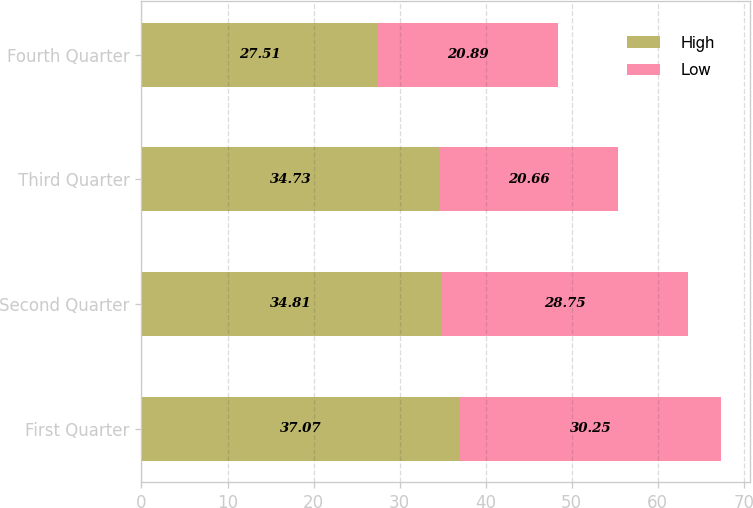Convert chart to OTSL. <chart><loc_0><loc_0><loc_500><loc_500><stacked_bar_chart><ecel><fcel>First Quarter<fcel>Second Quarter<fcel>Third Quarter<fcel>Fourth Quarter<nl><fcel>High<fcel>37.07<fcel>34.81<fcel>34.73<fcel>27.51<nl><fcel>Low<fcel>30.25<fcel>28.75<fcel>20.66<fcel>20.89<nl></chart> 